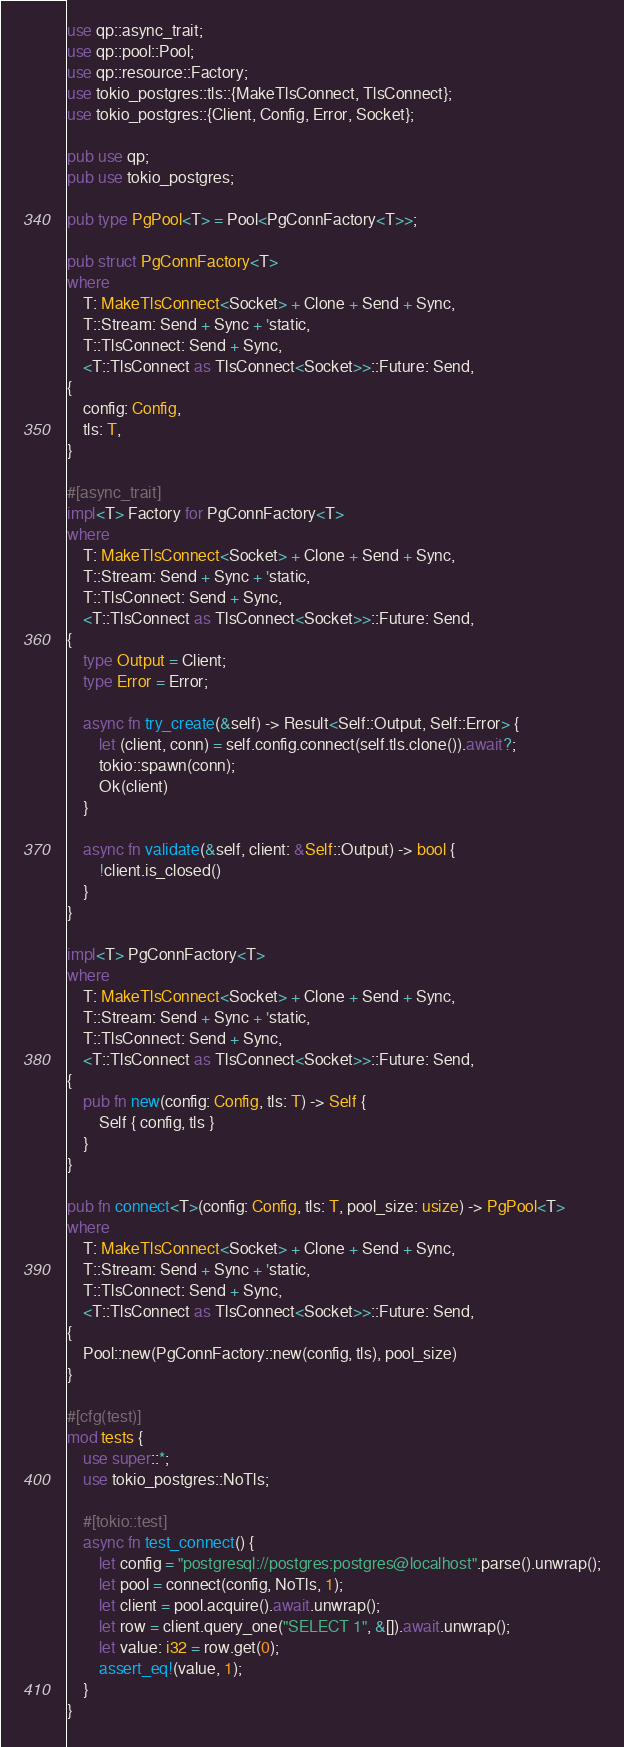Convert code to text. <code><loc_0><loc_0><loc_500><loc_500><_Rust_>use qp::async_trait;
use qp::pool::Pool;
use qp::resource::Factory;
use tokio_postgres::tls::{MakeTlsConnect, TlsConnect};
use tokio_postgres::{Client, Config, Error, Socket};

pub use qp;
pub use tokio_postgres;

pub type PgPool<T> = Pool<PgConnFactory<T>>;

pub struct PgConnFactory<T>
where
    T: MakeTlsConnect<Socket> + Clone + Send + Sync,
    T::Stream: Send + Sync + 'static,
    T::TlsConnect: Send + Sync,
    <T::TlsConnect as TlsConnect<Socket>>::Future: Send,
{
    config: Config,
    tls: T,
}

#[async_trait]
impl<T> Factory for PgConnFactory<T>
where
    T: MakeTlsConnect<Socket> + Clone + Send + Sync,
    T::Stream: Send + Sync + 'static,
    T::TlsConnect: Send + Sync,
    <T::TlsConnect as TlsConnect<Socket>>::Future: Send,
{
    type Output = Client;
    type Error = Error;

    async fn try_create(&self) -> Result<Self::Output, Self::Error> {
        let (client, conn) = self.config.connect(self.tls.clone()).await?;
        tokio::spawn(conn);
        Ok(client)
    }

    async fn validate(&self, client: &Self::Output) -> bool {
        !client.is_closed()
    }
}

impl<T> PgConnFactory<T>
where
    T: MakeTlsConnect<Socket> + Clone + Send + Sync,
    T::Stream: Send + Sync + 'static,
    T::TlsConnect: Send + Sync,
    <T::TlsConnect as TlsConnect<Socket>>::Future: Send,
{
    pub fn new(config: Config, tls: T) -> Self {
        Self { config, tls }
    }
}

pub fn connect<T>(config: Config, tls: T, pool_size: usize) -> PgPool<T>
where
    T: MakeTlsConnect<Socket> + Clone + Send + Sync,
    T::Stream: Send + Sync + 'static,
    T::TlsConnect: Send + Sync,
    <T::TlsConnect as TlsConnect<Socket>>::Future: Send,
{
    Pool::new(PgConnFactory::new(config, tls), pool_size)
}

#[cfg(test)]
mod tests {
    use super::*;
    use tokio_postgres::NoTls;

    #[tokio::test]
    async fn test_connect() {
        let config = "postgresql://postgres:postgres@localhost".parse().unwrap();
        let pool = connect(config, NoTls, 1);
        let client = pool.acquire().await.unwrap();
        let row = client.query_one("SELECT 1", &[]).await.unwrap();
        let value: i32 = row.get(0);
        assert_eq!(value, 1);
    }
}
</code> 